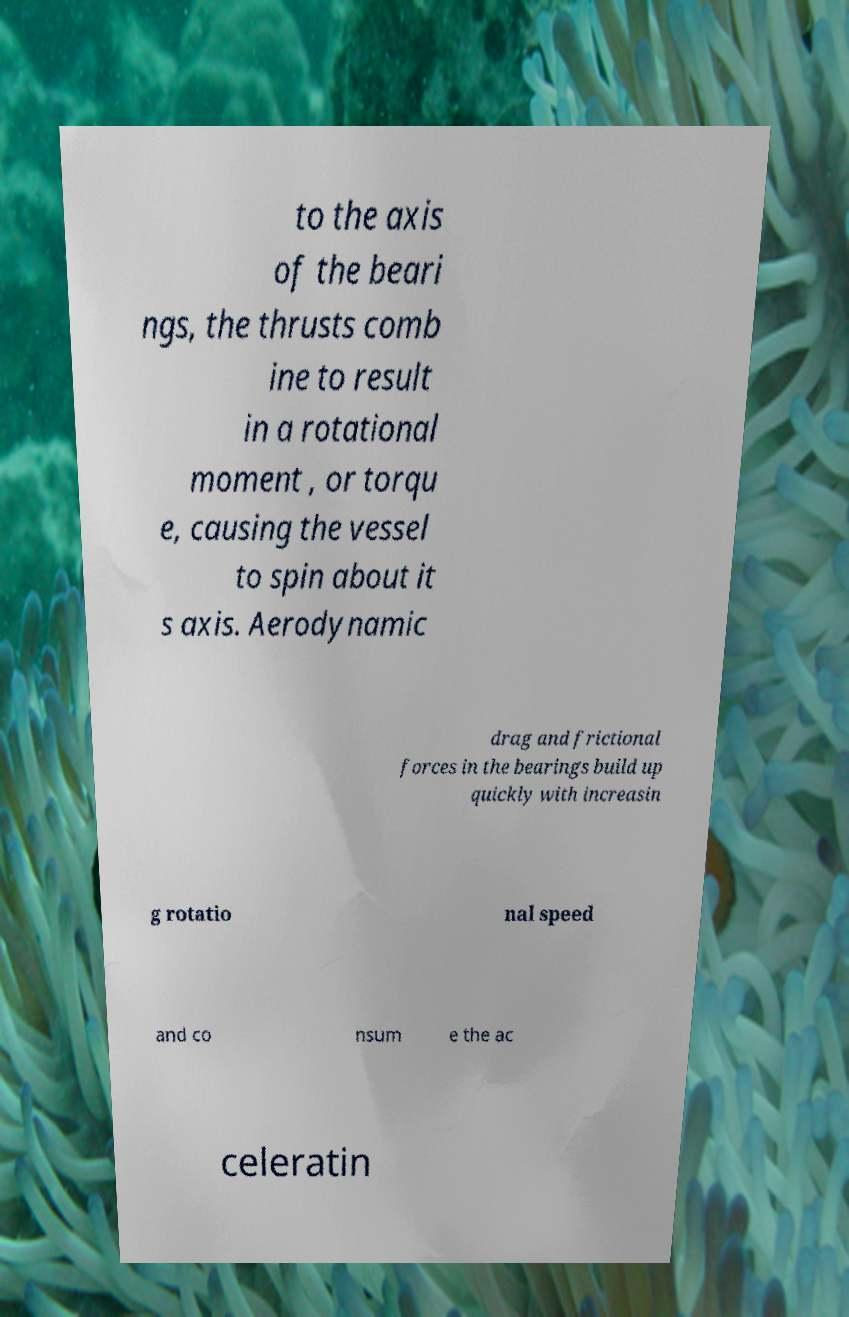What messages or text are displayed in this image? I need them in a readable, typed format. to the axis of the beari ngs, the thrusts comb ine to result in a rotational moment , or torqu e, causing the vessel to spin about it s axis. Aerodynamic drag and frictional forces in the bearings build up quickly with increasin g rotatio nal speed and co nsum e the ac celeratin 